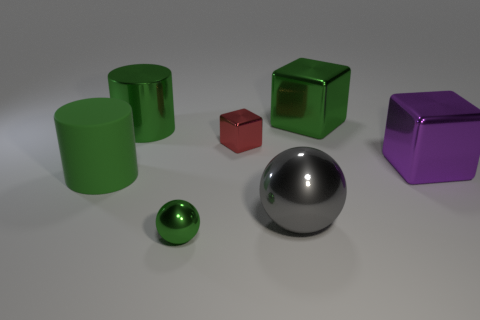Add 2 big purple metal objects. How many objects exist? 9 Subtract all balls. How many objects are left? 5 Subtract all gray metallic things. Subtract all large red matte spheres. How many objects are left? 6 Add 2 green metal spheres. How many green metal spheres are left? 3 Add 3 big purple shiny blocks. How many big purple shiny blocks exist? 4 Subtract 0 blue blocks. How many objects are left? 7 